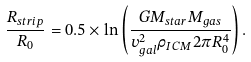Convert formula to latex. <formula><loc_0><loc_0><loc_500><loc_500>\frac { R _ { s t r i p } } { R _ { 0 } } = 0 . 5 \times \ln \left ( \frac { G M _ { s t a r } M _ { g a s } } { v _ { g a l } ^ { 2 } \rho _ { I C M } 2 \pi R _ { 0 } ^ { 4 } } \right ) .</formula> 